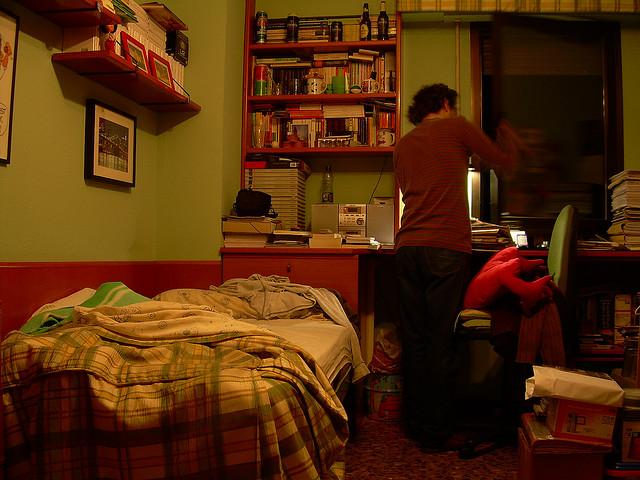What is in the room?

Choices:
A) bed
B) witch hat
C) pool table
D) refrigerator bed 